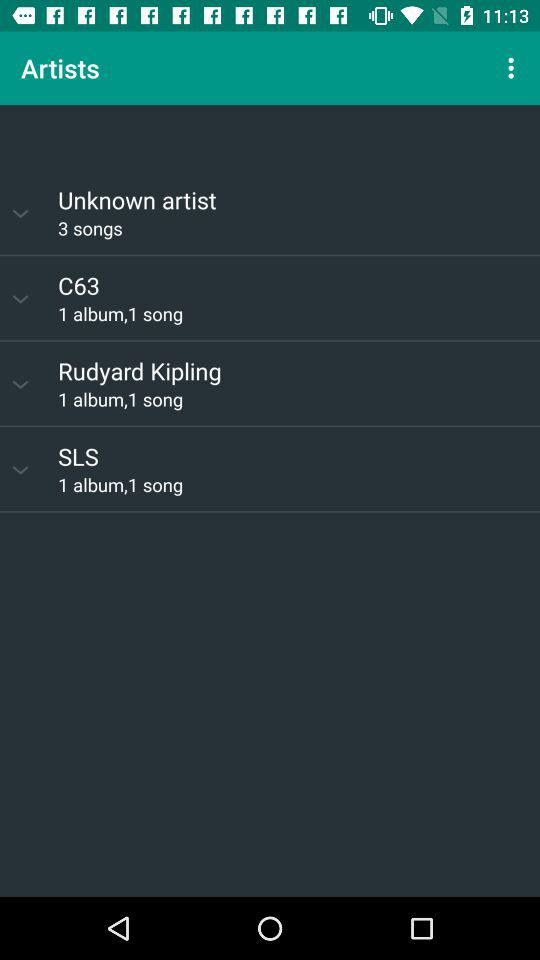How many albums are there by SLS? There is 1 album by SLS. 